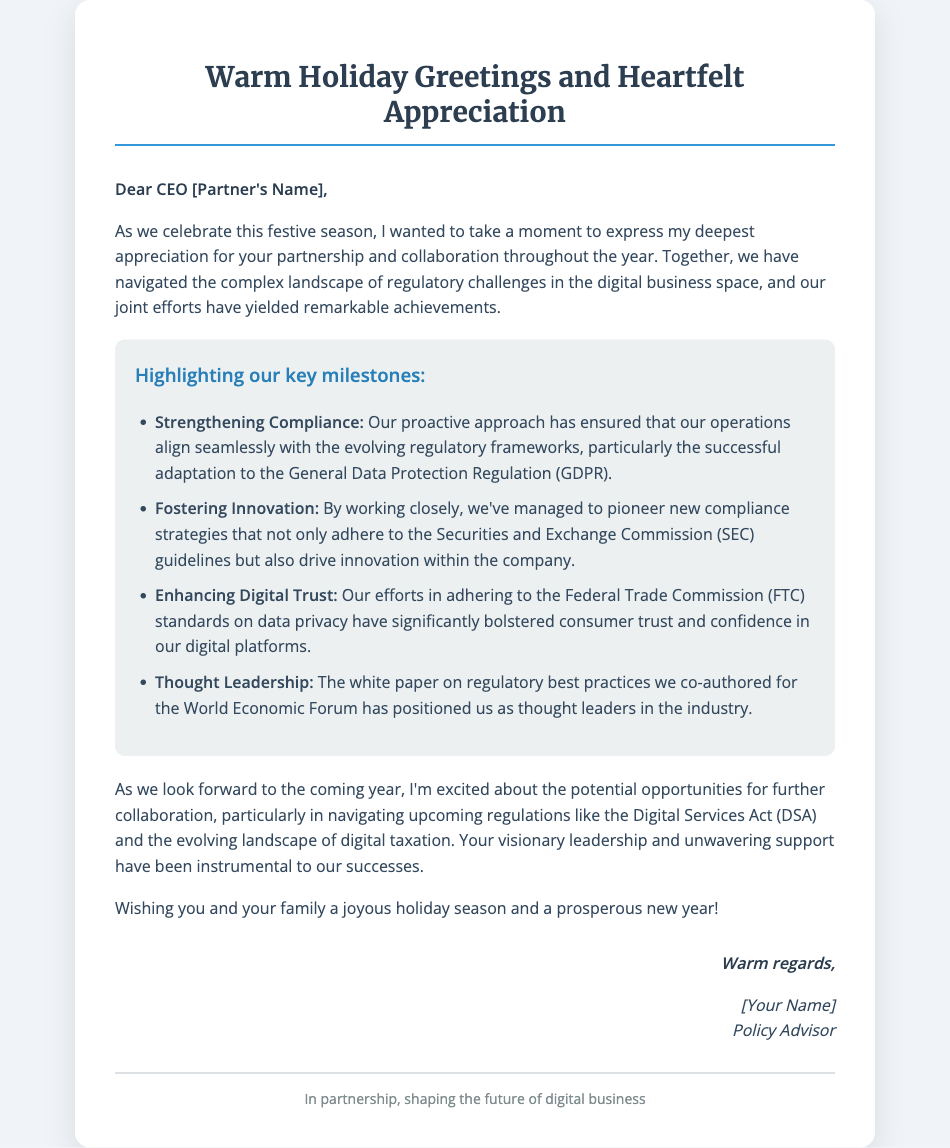What is the title of the greeting card? The title is prominently displayed at the top of the card and reads "Warm Holiday Greetings and Heartfelt Appreciation."
Answer: Warm Holiday Greetings and Heartfelt Appreciation Who is the greeting card addressed to? The salutation at the beginning addresses the recipient directly, indicating their role and name.
Answer: CEO [Partner's Name] What regulatory framework was mentioned regarding compliance? A specific regulation mentioned in the achievements section highlights the focus on compliance efforts.
Answer: General Data Protection Regulation (GDPR) How many key milestones are highlighted in the card? The card lists specific achievements, indicating the number of key milestones.
Answer: Four What is the overall tone of the message in the greeting card? The language used throughout the message reflects a positive and festive sentiment, common in holiday greetings.
Answer: Joyous What document type is this greeting card categorized as? This card serves a specific purpose during the holiday season, often used in business to convey appreciation.
Answer: Greeting Card Which body of authority's guidelines are referenced in the document? The achievements in the card mention guidelines from a specific regulatory body.
Answer: Securities and Exchange Commission (SEC) What is the sender's position? The position of the sender is mentioned in the signature area of the card.
Answer: Policy Advisor 